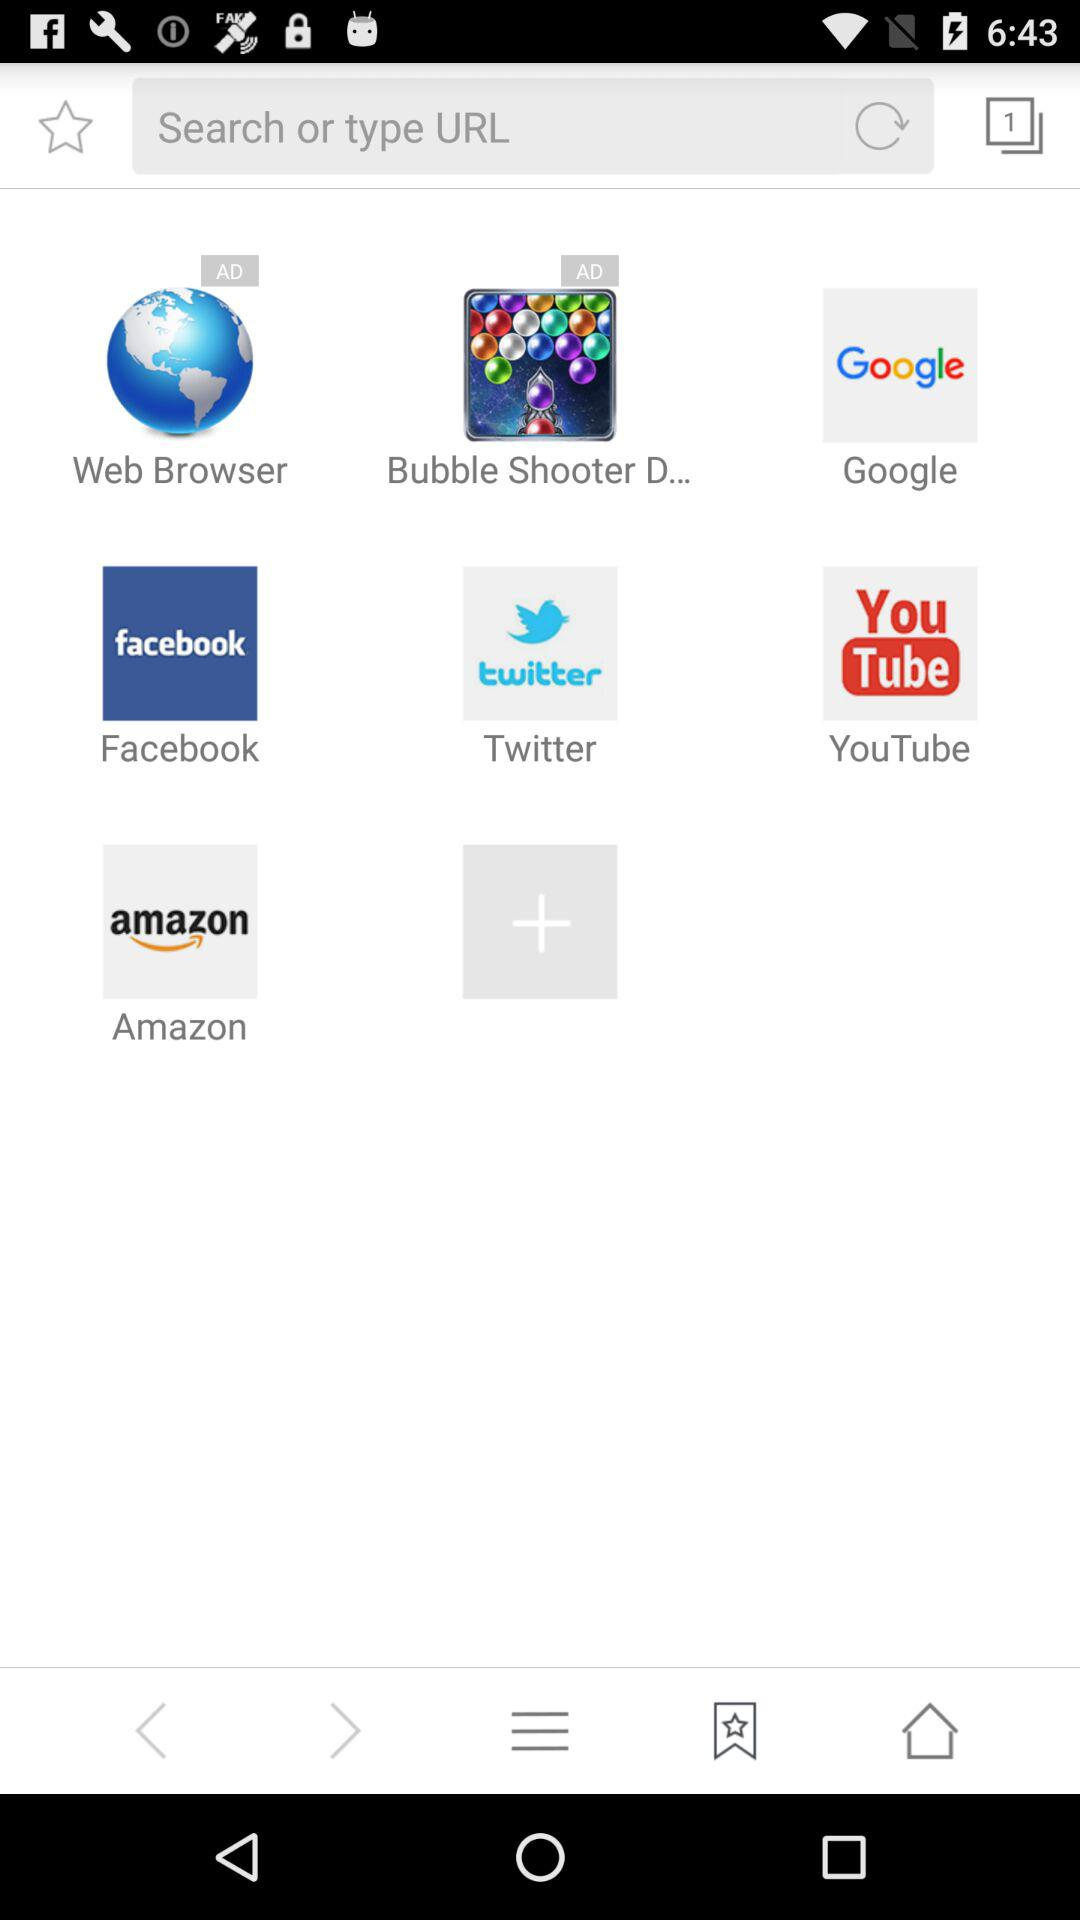How many unread notifications are there?
When the provided information is insufficient, respond with <no answer>. <no answer> 